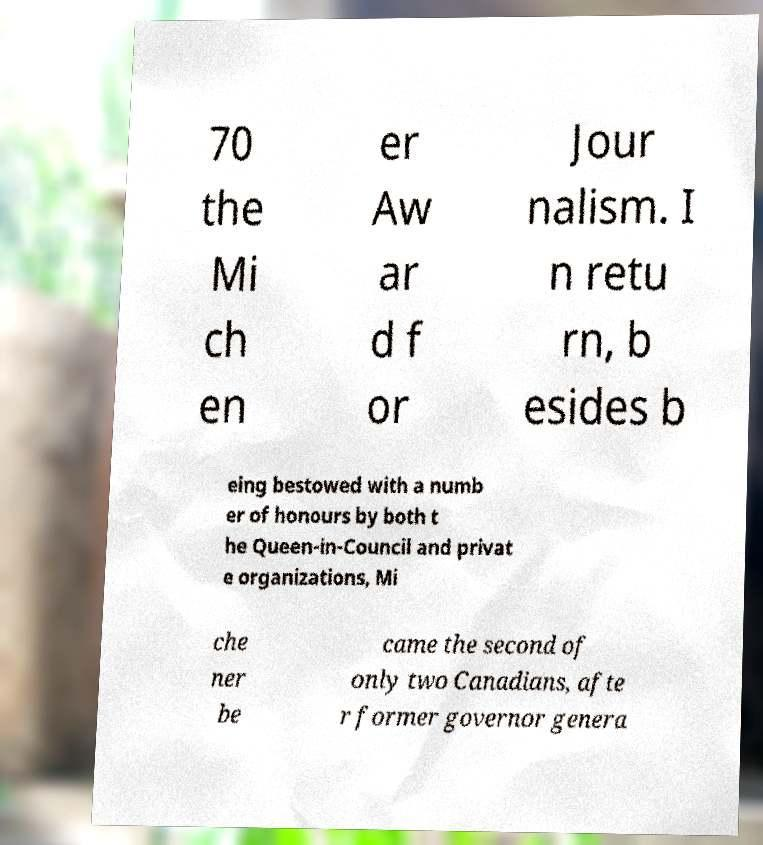Could you extract and type out the text from this image? 70 the Mi ch en er Aw ar d f or Jour nalism. I n retu rn, b esides b eing bestowed with a numb er of honours by both t he Queen-in-Council and privat e organizations, Mi che ner be came the second of only two Canadians, afte r former governor genera 